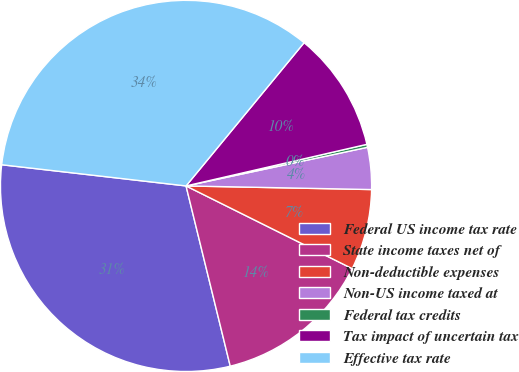Convert chart. <chart><loc_0><loc_0><loc_500><loc_500><pie_chart><fcel>Federal US income tax rate<fcel>State income taxes net of<fcel>Non-deductible expenses<fcel>Non-US income taxed at<fcel>Federal tax credits<fcel>Tax impact of uncertain tax<fcel>Effective tax rate<nl><fcel>30.65%<fcel>13.82%<fcel>7.04%<fcel>3.65%<fcel>0.26%<fcel>10.43%<fcel>34.15%<nl></chart> 